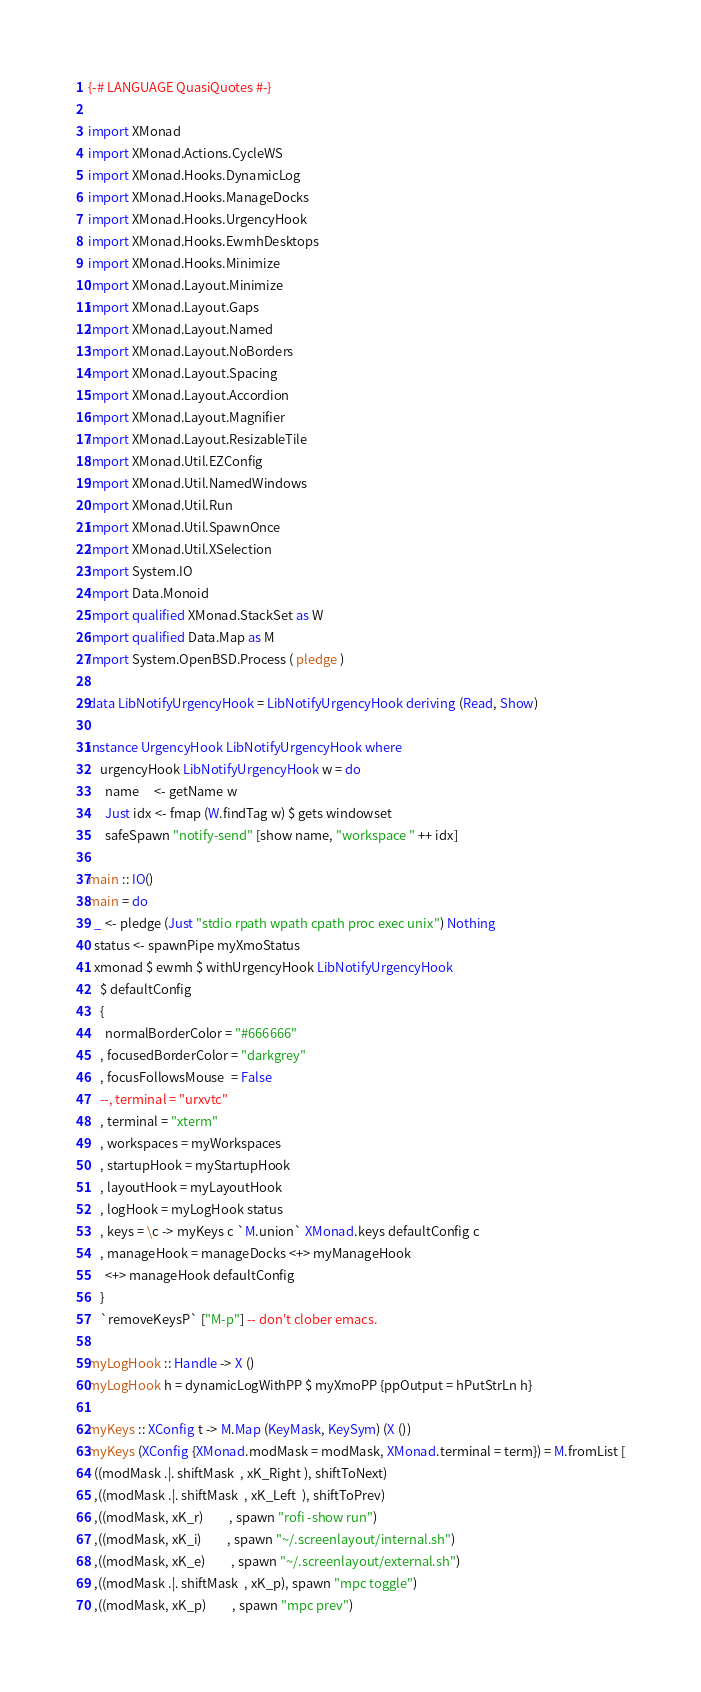<code> <loc_0><loc_0><loc_500><loc_500><_Haskell_>{-# LANGUAGE QuasiQuotes #-}

import XMonad
import XMonad.Actions.CycleWS
import XMonad.Hooks.DynamicLog
import XMonad.Hooks.ManageDocks
import XMonad.Hooks.UrgencyHook
import XMonad.Hooks.EwmhDesktops
import XMonad.Hooks.Minimize
import XMonad.Layout.Minimize
import XMonad.Layout.Gaps
import XMonad.Layout.Named
import XMonad.Layout.NoBorders
import XMonad.Layout.Spacing
import XMonad.Layout.Accordion
import XMonad.Layout.Magnifier
import XMonad.Layout.ResizableTile
import XMonad.Util.EZConfig
import XMonad.Util.NamedWindows
import XMonad.Util.Run
import XMonad.Util.SpawnOnce
import XMonad.Util.XSelection
import System.IO
import Data.Monoid
import qualified XMonad.StackSet as W
import qualified Data.Map as M
import System.OpenBSD.Process ( pledge )    

data LibNotifyUrgencyHook = LibNotifyUrgencyHook deriving (Read, Show)

instance UrgencyHook LibNotifyUrgencyHook where
    urgencyHook LibNotifyUrgencyHook w = do
      name     <- getName w
      Just idx <- fmap (W.findTag w) $ gets windowset
      safeSpawn "notify-send" [show name, "workspace " ++ idx]

main :: IO()
main = do
  _ <- pledge (Just "stdio rpath wpath cpath proc exec unix") Nothing
  status <- spawnPipe myXmoStatus
  xmonad $ ewmh $ withUrgencyHook LibNotifyUrgencyHook
    $ defaultConfig
    {
      normalBorderColor = "#666666"
    , focusedBorderColor = "darkgrey"
    , focusFollowsMouse  = False
    --, terminal = "urxvtc"
    , terminal = "xterm"
    , workspaces = myWorkspaces
    , startupHook = myStartupHook
    , layoutHook = myLayoutHook
    , logHook = myLogHook status
    , keys = \c -> myKeys c `M.union` XMonad.keys defaultConfig c
    , manageHook = manageDocks <+> myManageHook
      <+> manageHook defaultConfig
    }
    `removeKeysP` ["M-p"] -- don't clober emacs.

myLogHook :: Handle -> X ()
myLogHook h = dynamicLogWithPP $ myXmoPP {ppOutput = hPutStrLn h}

myKeys :: XConfig t -> M.Map (KeyMask, KeySym) (X ())
myKeys (XConfig {XMonad.modMask = modMask, XMonad.terminal = term}) = M.fromList [
  ((modMask .|. shiftMask  , xK_Right ), shiftToNext)
  ,((modMask .|. shiftMask  , xK_Left  ), shiftToPrev)
  ,((modMask, xK_r)         , spawn "rofi -show run")
  ,((modMask, xK_i)         , spawn "~/.screenlayout/internal.sh")
  ,((modMask, xK_e)         , spawn "~/.screenlayout/external.sh")
  ,((modMask .|. shiftMask  , xK_p), spawn "mpc toggle")
  ,((modMask, xK_p)         , spawn "mpc prev")</code> 